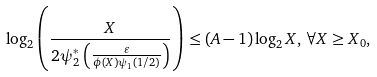<formula> <loc_0><loc_0><loc_500><loc_500>\log _ { 2 } \left ( \frac { X } { 2 \psi _ { 2 } ^ { * } \left ( \frac { \varepsilon } { \phi ( X ) \psi _ { 1 } ( 1 / 2 ) } \right ) } \right ) \leq ( A - 1 ) \log _ { 2 } X , \, \forall X \geq X _ { 0 } ,</formula> 